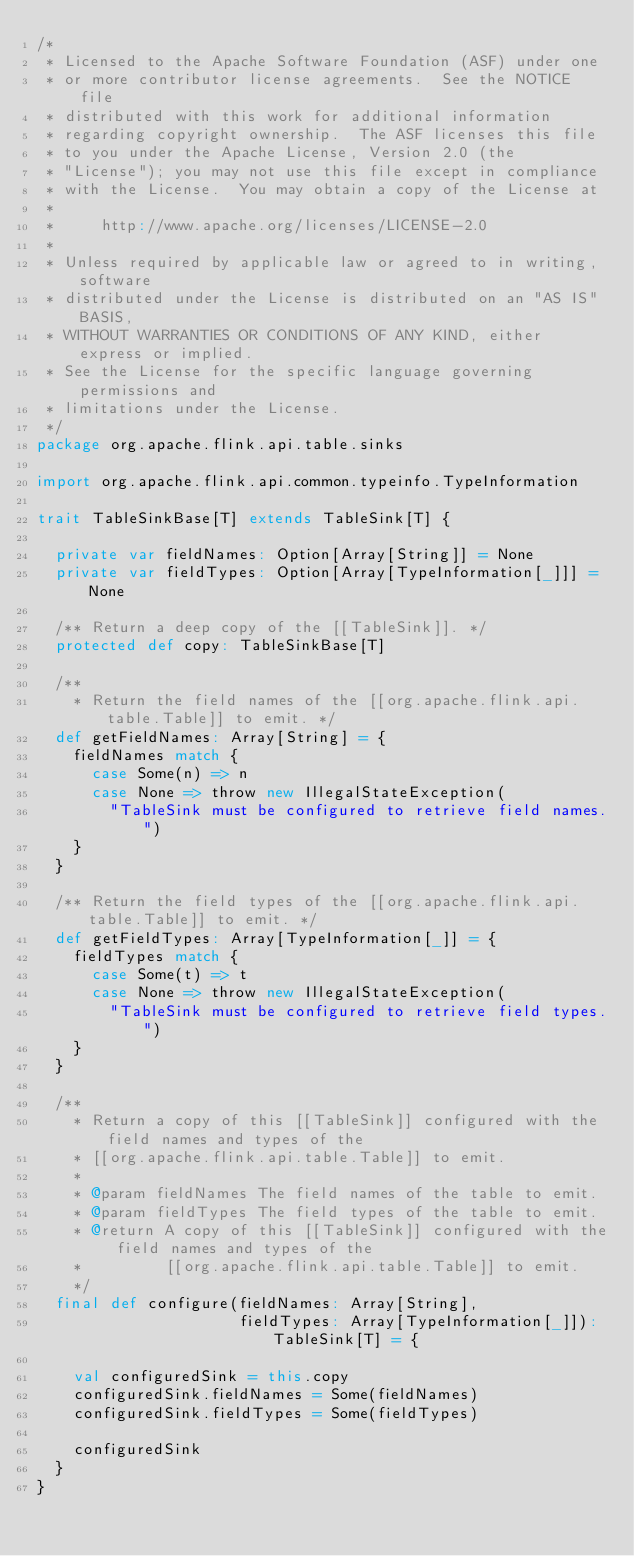<code> <loc_0><loc_0><loc_500><loc_500><_Scala_>/*
 * Licensed to the Apache Software Foundation (ASF) under one
 * or more contributor license agreements.  See the NOTICE file
 * distributed with this work for additional information
 * regarding copyright ownership.  The ASF licenses this file
 * to you under the Apache License, Version 2.0 (the
 * "License"); you may not use this file except in compliance
 * with the License.  You may obtain a copy of the License at
 *
 *     http://www.apache.org/licenses/LICENSE-2.0
 *
 * Unless required by applicable law or agreed to in writing, software
 * distributed under the License is distributed on an "AS IS" BASIS,
 * WITHOUT WARRANTIES OR CONDITIONS OF ANY KIND, either express or implied.
 * See the License for the specific language governing permissions and
 * limitations under the License.
 */
package org.apache.flink.api.table.sinks

import org.apache.flink.api.common.typeinfo.TypeInformation

trait TableSinkBase[T] extends TableSink[T] {

  private var fieldNames: Option[Array[String]] = None
  private var fieldTypes: Option[Array[TypeInformation[_]]] = None

  /** Return a deep copy of the [[TableSink]]. */
  protected def copy: TableSinkBase[T]

  /**
    * Return the field names of the [[org.apache.flink.api.table.Table]] to emit. */
  def getFieldNames: Array[String] = {
    fieldNames match {
      case Some(n) => n
      case None => throw new IllegalStateException(
        "TableSink must be configured to retrieve field names.")
    }
  }

  /** Return the field types of the [[org.apache.flink.api.table.Table]] to emit. */
  def getFieldTypes: Array[TypeInformation[_]] = {
    fieldTypes match {
      case Some(t) => t
      case None => throw new IllegalStateException(
        "TableSink must be configured to retrieve field types.")
    }
  }

  /**
    * Return a copy of this [[TableSink]] configured with the field names and types of the
    * [[org.apache.flink.api.table.Table]] to emit.
    *
    * @param fieldNames The field names of the table to emit.
    * @param fieldTypes The field types of the table to emit.
    * @return A copy of this [[TableSink]] configured with the field names and types of the
    *         [[org.apache.flink.api.table.Table]] to emit.
    */
  final def configure(fieldNames: Array[String],
                      fieldTypes: Array[TypeInformation[_]]): TableSink[T] = {

    val configuredSink = this.copy
    configuredSink.fieldNames = Some(fieldNames)
    configuredSink.fieldTypes = Some(fieldTypes)

    configuredSink
  }
}
</code> 